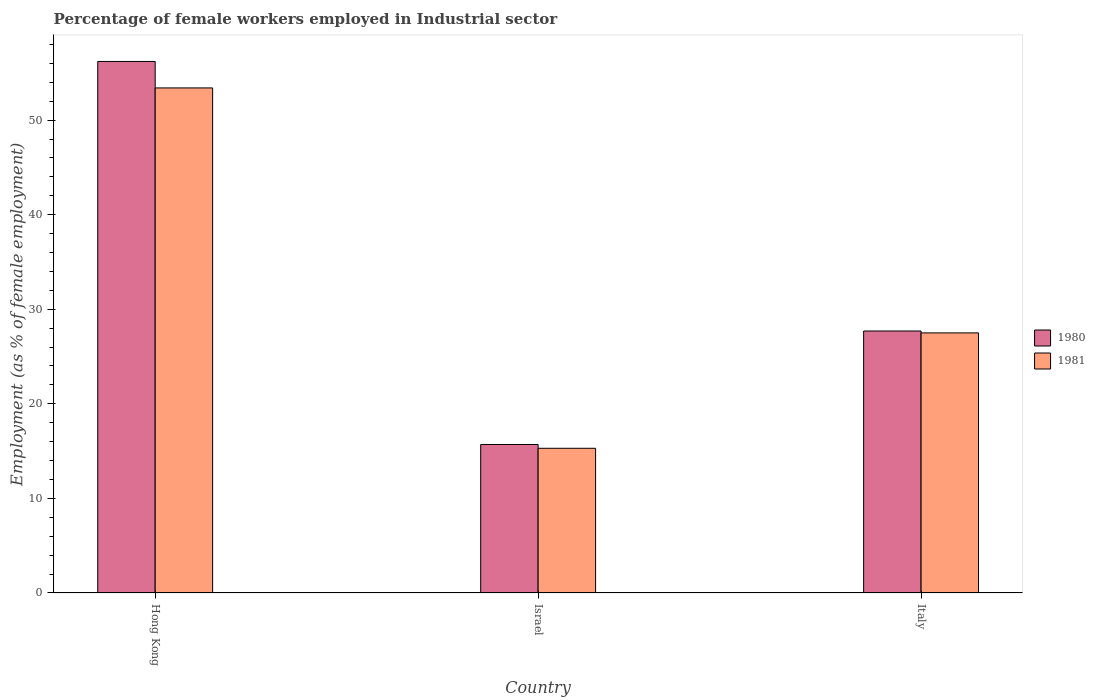Are the number of bars on each tick of the X-axis equal?
Your answer should be very brief. Yes. How many bars are there on the 2nd tick from the right?
Ensure brevity in your answer.  2. What is the percentage of females employed in Industrial sector in 1980 in Hong Kong?
Your response must be concise. 56.2. Across all countries, what is the maximum percentage of females employed in Industrial sector in 1981?
Your answer should be very brief. 53.4. Across all countries, what is the minimum percentage of females employed in Industrial sector in 1981?
Give a very brief answer. 15.3. In which country was the percentage of females employed in Industrial sector in 1980 maximum?
Offer a very short reply. Hong Kong. What is the total percentage of females employed in Industrial sector in 1980 in the graph?
Make the answer very short. 99.6. What is the difference between the percentage of females employed in Industrial sector in 1980 in Israel and that in Italy?
Give a very brief answer. -12. What is the difference between the percentage of females employed in Industrial sector in 1980 in Hong Kong and the percentage of females employed in Industrial sector in 1981 in Italy?
Keep it short and to the point. 28.7. What is the average percentage of females employed in Industrial sector in 1980 per country?
Provide a succinct answer. 33.2. What is the difference between the percentage of females employed in Industrial sector of/in 1980 and percentage of females employed in Industrial sector of/in 1981 in Hong Kong?
Provide a succinct answer. 2.8. In how many countries, is the percentage of females employed in Industrial sector in 1981 greater than 38 %?
Ensure brevity in your answer.  1. What is the ratio of the percentage of females employed in Industrial sector in 1981 in Hong Kong to that in Italy?
Keep it short and to the point. 1.94. Is the percentage of females employed in Industrial sector in 1981 in Hong Kong less than that in Israel?
Make the answer very short. No. What is the difference between the highest and the second highest percentage of females employed in Industrial sector in 1981?
Provide a short and direct response. -25.9. What is the difference between the highest and the lowest percentage of females employed in Industrial sector in 1980?
Offer a very short reply. 40.5. Is the sum of the percentage of females employed in Industrial sector in 1981 in Hong Kong and Italy greater than the maximum percentage of females employed in Industrial sector in 1980 across all countries?
Your answer should be very brief. Yes. What does the 1st bar from the right in Hong Kong represents?
Offer a terse response. 1981. Are all the bars in the graph horizontal?
Offer a terse response. No. What is the difference between two consecutive major ticks on the Y-axis?
Make the answer very short. 10. Does the graph contain any zero values?
Your response must be concise. No. Does the graph contain grids?
Ensure brevity in your answer.  No. How many legend labels are there?
Your answer should be very brief. 2. How are the legend labels stacked?
Make the answer very short. Vertical. What is the title of the graph?
Ensure brevity in your answer.  Percentage of female workers employed in Industrial sector. Does "1964" appear as one of the legend labels in the graph?
Your response must be concise. No. What is the label or title of the Y-axis?
Your answer should be very brief. Employment (as % of female employment). What is the Employment (as % of female employment) in 1980 in Hong Kong?
Make the answer very short. 56.2. What is the Employment (as % of female employment) in 1981 in Hong Kong?
Offer a very short reply. 53.4. What is the Employment (as % of female employment) of 1980 in Israel?
Your answer should be very brief. 15.7. What is the Employment (as % of female employment) of 1981 in Israel?
Provide a succinct answer. 15.3. What is the Employment (as % of female employment) of 1980 in Italy?
Offer a terse response. 27.7. What is the Employment (as % of female employment) of 1981 in Italy?
Offer a terse response. 27.5. Across all countries, what is the maximum Employment (as % of female employment) in 1980?
Offer a very short reply. 56.2. Across all countries, what is the maximum Employment (as % of female employment) of 1981?
Make the answer very short. 53.4. Across all countries, what is the minimum Employment (as % of female employment) of 1980?
Keep it short and to the point. 15.7. Across all countries, what is the minimum Employment (as % of female employment) in 1981?
Your answer should be very brief. 15.3. What is the total Employment (as % of female employment) in 1980 in the graph?
Make the answer very short. 99.6. What is the total Employment (as % of female employment) of 1981 in the graph?
Your answer should be very brief. 96.2. What is the difference between the Employment (as % of female employment) of 1980 in Hong Kong and that in Israel?
Offer a very short reply. 40.5. What is the difference between the Employment (as % of female employment) of 1981 in Hong Kong and that in Israel?
Your answer should be compact. 38.1. What is the difference between the Employment (as % of female employment) of 1980 in Hong Kong and that in Italy?
Your response must be concise. 28.5. What is the difference between the Employment (as % of female employment) of 1981 in Hong Kong and that in Italy?
Offer a very short reply. 25.9. What is the difference between the Employment (as % of female employment) of 1980 in Israel and that in Italy?
Offer a very short reply. -12. What is the difference between the Employment (as % of female employment) in 1980 in Hong Kong and the Employment (as % of female employment) in 1981 in Israel?
Give a very brief answer. 40.9. What is the difference between the Employment (as % of female employment) in 1980 in Hong Kong and the Employment (as % of female employment) in 1981 in Italy?
Your response must be concise. 28.7. What is the difference between the Employment (as % of female employment) of 1980 in Israel and the Employment (as % of female employment) of 1981 in Italy?
Offer a terse response. -11.8. What is the average Employment (as % of female employment) of 1980 per country?
Ensure brevity in your answer.  33.2. What is the average Employment (as % of female employment) of 1981 per country?
Your answer should be compact. 32.07. What is the ratio of the Employment (as % of female employment) of 1980 in Hong Kong to that in Israel?
Give a very brief answer. 3.58. What is the ratio of the Employment (as % of female employment) in 1981 in Hong Kong to that in Israel?
Your answer should be very brief. 3.49. What is the ratio of the Employment (as % of female employment) of 1980 in Hong Kong to that in Italy?
Your response must be concise. 2.03. What is the ratio of the Employment (as % of female employment) in 1981 in Hong Kong to that in Italy?
Offer a very short reply. 1.94. What is the ratio of the Employment (as % of female employment) of 1980 in Israel to that in Italy?
Your response must be concise. 0.57. What is the ratio of the Employment (as % of female employment) of 1981 in Israel to that in Italy?
Your answer should be compact. 0.56. What is the difference between the highest and the second highest Employment (as % of female employment) in 1981?
Your answer should be very brief. 25.9. What is the difference between the highest and the lowest Employment (as % of female employment) in 1980?
Provide a short and direct response. 40.5. What is the difference between the highest and the lowest Employment (as % of female employment) of 1981?
Make the answer very short. 38.1. 